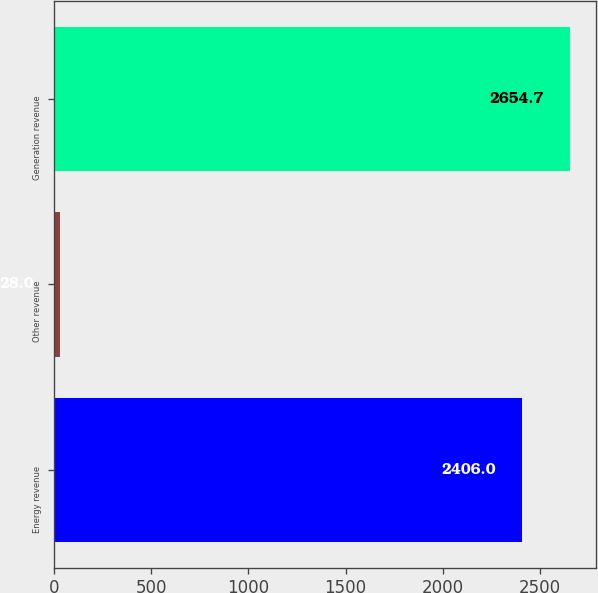<chart> <loc_0><loc_0><loc_500><loc_500><bar_chart><fcel>Energy revenue<fcel>Other revenue<fcel>Generation revenue<nl><fcel>2406<fcel>28<fcel>2654.7<nl></chart> 